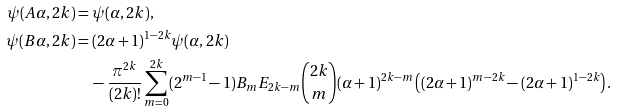Convert formula to latex. <formula><loc_0><loc_0><loc_500><loc_500>\psi ( A \alpha , 2 k ) & = \psi ( \alpha , 2 k ) , \\ \psi ( B \alpha , 2 k ) & = ( 2 \alpha + 1 ) ^ { 1 - 2 k } \psi ( \alpha , 2 k ) \\ & \quad - \frac { \pi ^ { 2 k } } { ( 2 k ) ! } \sum _ { m = 0 } ^ { 2 k } ( 2 ^ { m - 1 } - 1 ) B _ { m } E _ { 2 k - m } \binom { 2 k } { m } ( \alpha + 1 ) ^ { 2 k - m } \left ( ( 2 \alpha + 1 ) ^ { m - 2 k } - ( 2 \alpha + 1 ) ^ { 1 - 2 k } \right ) .</formula> 